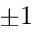Convert formula to latex. <formula><loc_0><loc_0><loc_500><loc_500>\pm 1</formula> 